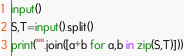Convert code to text. <code><loc_0><loc_0><loc_500><loc_500><_Python_>input()
S,T=input().split()
print("".join([a+b for a,b in zip(S,T)]))</code> 